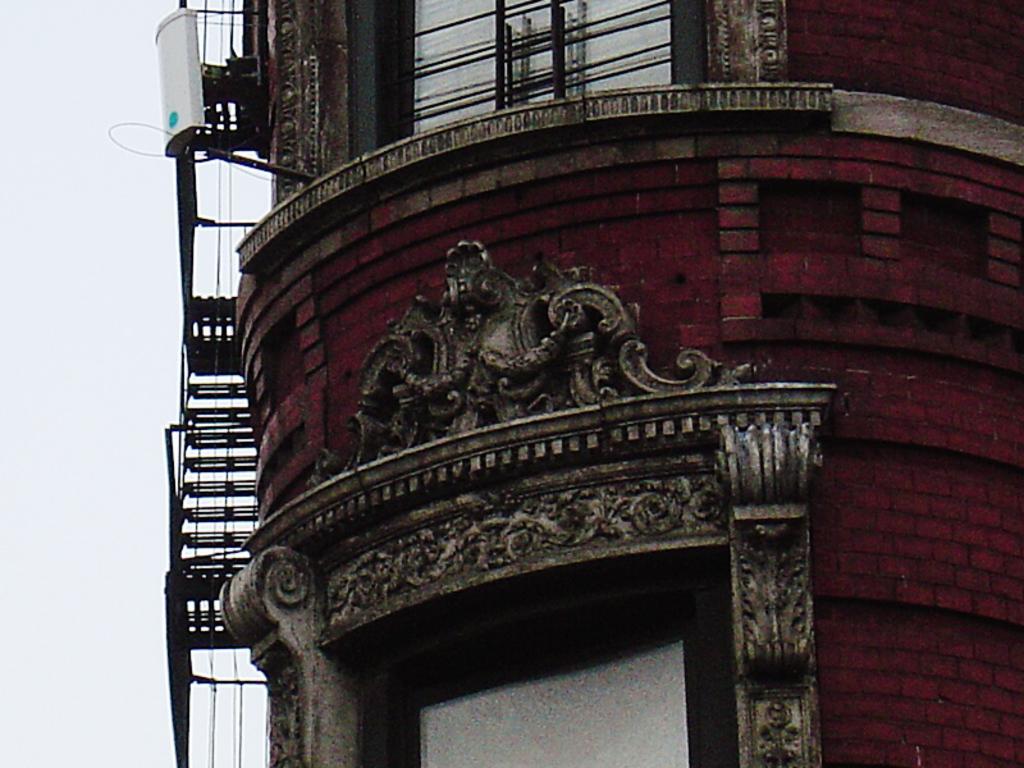How would you summarize this image in a sentence or two? In this image I can see a building which is red, cream and black in color and I can see few windows of the building. I can see few stairs, the railing and a white colored object to the building. In the background I can see the sky. 